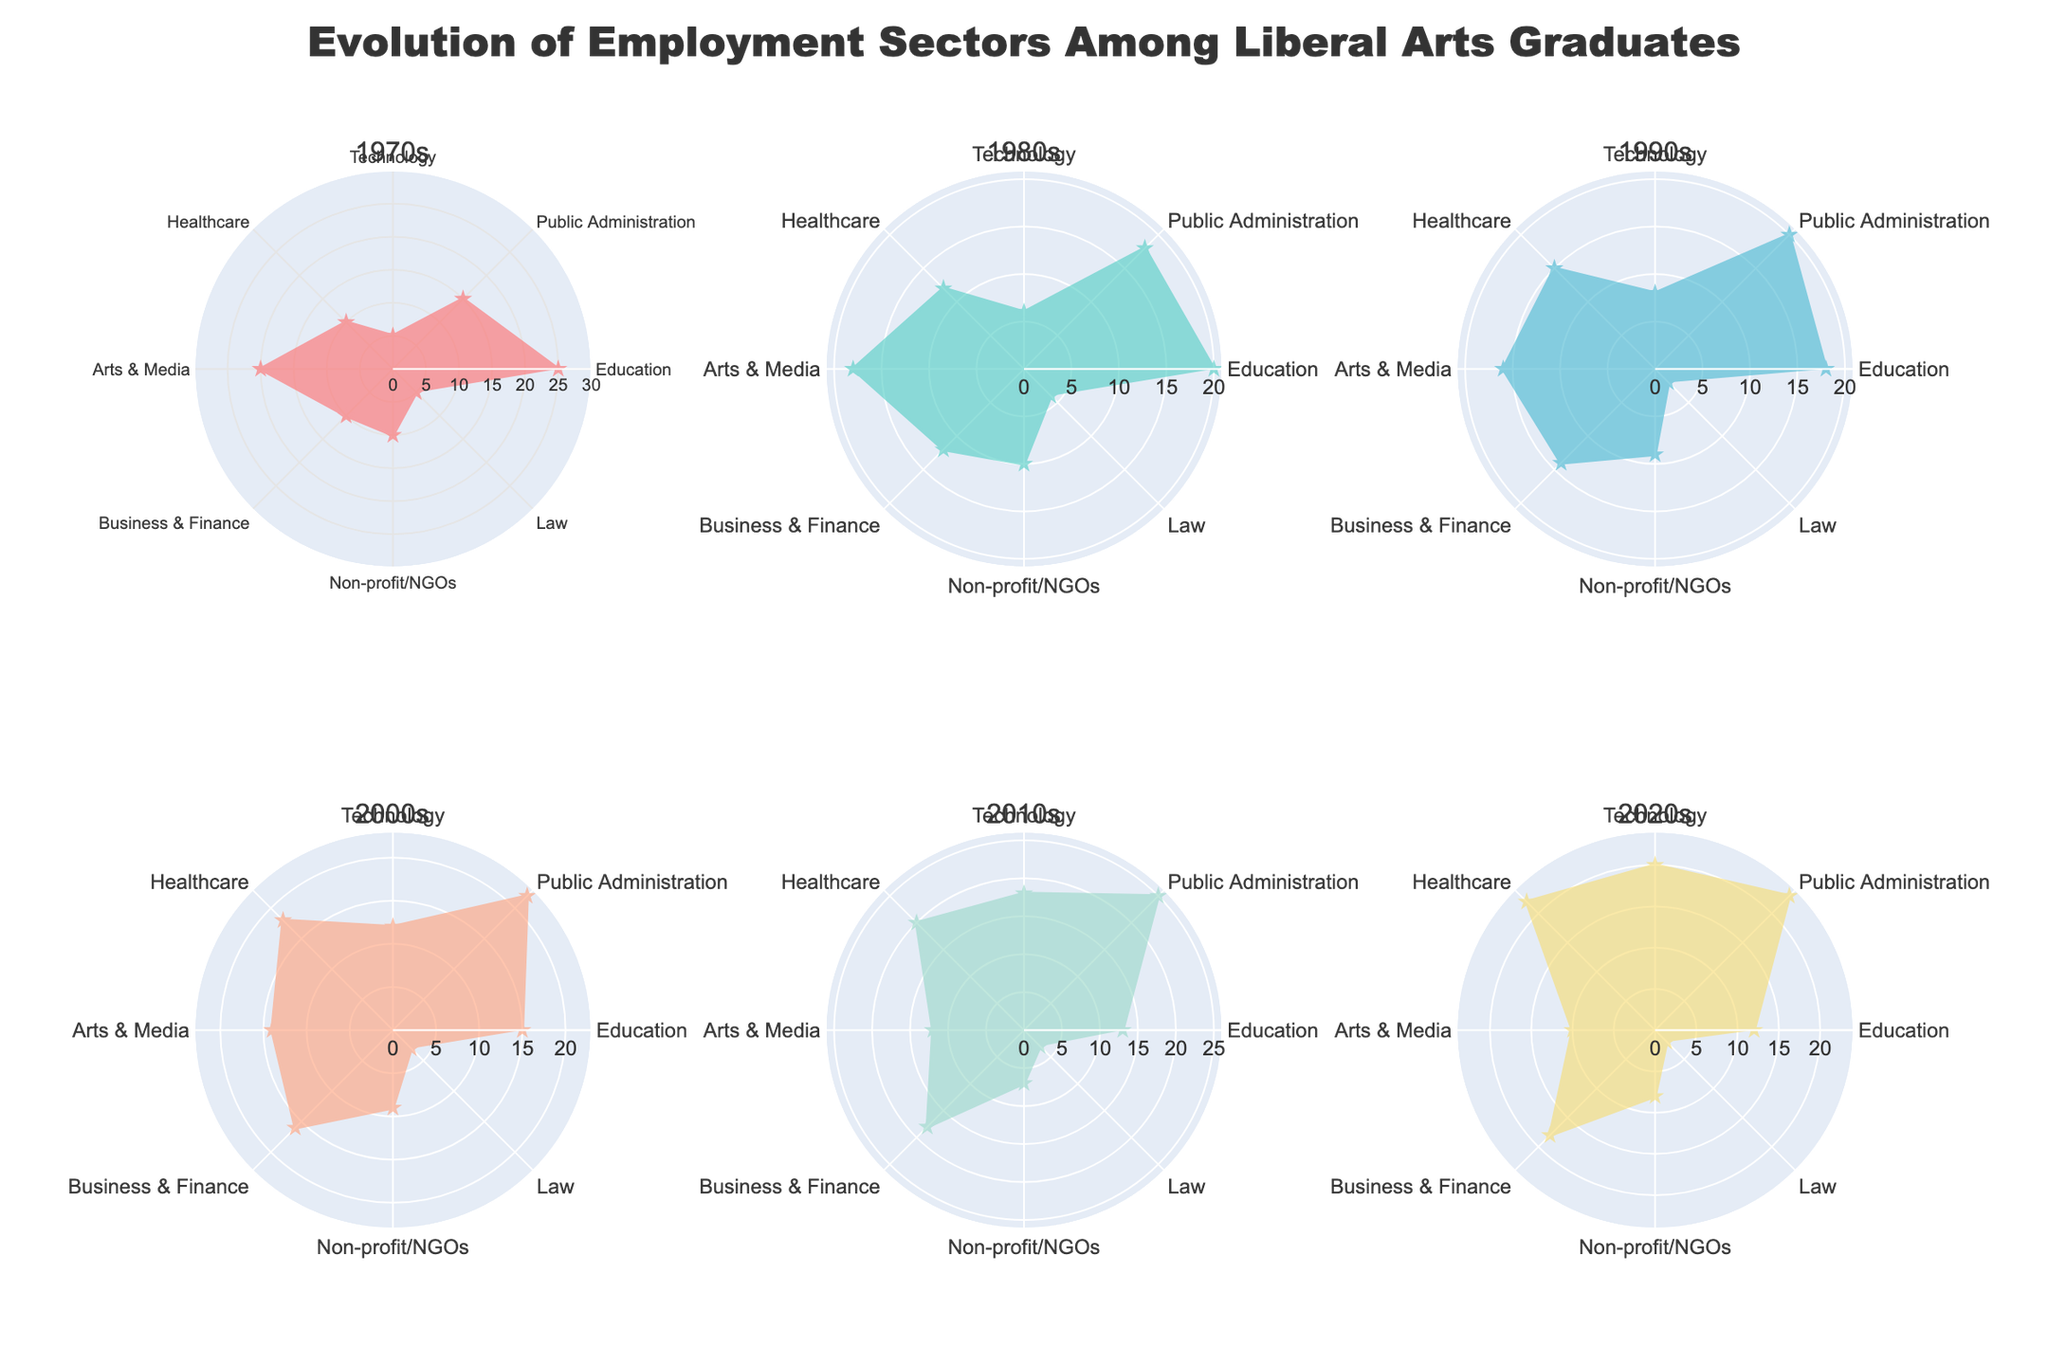What's the overall trend for the Education sector from the 1970s to the 2020s? Observing the radial distance of the Education sector in each subplot (decade), it starts high at 25 in the 1970s and gradually decreases to 12 in the 2020s. This shows a downward trend.
Answer: Downward trend Which sector has the highest value in the 2020s? In the 2020s subplot, the Technology sector has the highest radial distance (20), which is greater than all other sectors.
Answer: Technology What is the difference in the percentage of graduates in the Healthcare sector between the 1970s and the 2020s? The radial distance for Healthcare is 10 in the 1970s and 22 in the 2020s. The difference is 22 - 10 = 12 percentage points.
Answer: 12 How does the Arts & Media sector evolve from the 1970s to the 2020s? Arts & Media starts with a relatively high value of 20 in the 1970s, then decreases every decade to eventually reach 10 in the 2020s. This shows a consistent decline.
Answer: Consistent decline Which decade shows the lowest percentage for the Law sector? By comparing the radial distances for the Law sector across all subplots, the 1990s have the lowest value of 2.
Answer: 1990s Compare the trends of Technology and Business & Finance from the 1970s to the 2020s. Technology starts at 5 and steadily increases to 20, while Business & Finance starts at 10 and increases more moderately to 18. Both sectors show upward trends, but Technology’s growth is steeper.
Answer: Technology has a steeper upward trend What is the average percentage of graduates in the Public Administration sector over all decades? The values for Public Administration are 15, 18, 20, 22, 25, and 23. The sum is 123, and there are 6 decades, so the average is 123/6 = 20.5.
Answer: 20.5 Which sector shows the most volatility over the decades? By comparing the variation in radial distances, the Law sector shows the most notable dips, especially with values like 5, 4, 2, 3, 3, and 2, indicating high volatility.
Answer: Law In which sector do graduates have almost unchanged employment percentage over the decades? Observing the radial distances, Non-profit/NGOs remain relatively steady with values of 10, 10, 9, 9, 7, and 8.
Answer: Non-profit/NGOs 